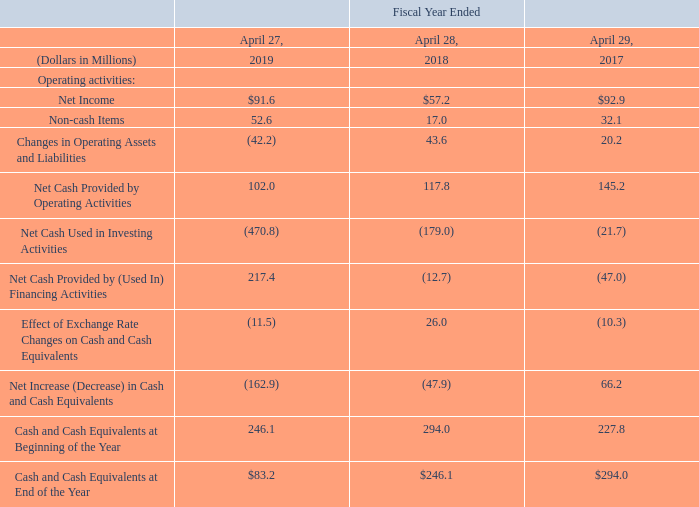Financial Condition, Liquidity and Capital Resources
We believe our current world-wide cash balances together with expected future cash flows to be generated from operations and our committed credit facility will be sufficient to support current operations. A significant amount of cash and expected future cash flows are located outside of the U.S. Of the $83.2 million of cash and cash equivalents as of April 27, 2019, $69.9 million was held in subsidiaries outside the U.S. and can be repatriated, primarily through the repayment of intercompany loans and the payment of dividends, without creating material additional income tax expense.
Cash flow is summarized below:
Operating Activities — Fiscal 2019 Compared to Fiscal 2018
Net cash provided by operating activities decreased $15.8 million to $102.0 million for fiscal 2019, compared to $117.8 million for fiscal 2018. The decrease was due to lower cash generated from changes in operating assets and liabilities, partially offset by higher net income adjusted for non-cash items. The $42.2 million of cash outflows for operating assets and liabilities was primarily due to higher prepaid expenses and other assets and lower accounts payable and accrued expenses.
Operating Activities — Fiscal 2018 Compared to Fiscal 2017
Net cash provided by operating activities decreased $27.4 million to $117.8 million in fiscal 2018, compared to $145.2 million in fiscal 2017. The decrease was primarily due to lower net income adjusted for non-cash items, partially offset by cash generated from changes in operating assets and liabilities. The $43.6 million of cash inflows for operating assets and liabilities was due to higher accounts payable and accrued expenses and lower prepaid expenses and other assets, offset by higher inventory levels.
Investing Activities — Fiscal 2019 Compared to Fiscal 2018
Net cash used in investing activities increased by $291.8 million to $470.8 million in fiscal 2019, compared to $179.0 million in fiscal 2018, primarily due to acquisitions. In fiscal 2019, we paid $422.1 million for the acquisition of Grakon. In fiscal 2018, we paid $130.9 million for the acquisitions of Pacific Insight and Procoplast.
Investing Activities — Fiscal 2018 Compared to Fiscal 2017
Net cash used in investing activities increased by $157.3 million to $179.0 million in fiscal 2018, compared to $21.7 million in fiscal 2017. The increase was primarily due to $130.9 million paid for the acquisitions of Pacific Insight and Procoplast. In addition, purchases of property, plant and equipment for our operations were higher in fiscal 2018 compared to fiscal 2017.
Financing Activities — Fiscal 2019 Compared to Fiscal 2018
Net cash provided by financing activities was $217.4 million in fiscal 2019, compared to net cash used in financing activities of $12.7 million in fiscal 2018. During fiscal 2019, we had net borrowings of $238.5 million which was partially used to fund the acquisition of Grakon. We paid dividends of $16.3 million in fiscal 2019, compared to $14.7 million in fiscal 2018.
Financing Activities — Fiscal 2018 Compared to Fiscal 2017
Net cash used in financing activities decreased $34.3 million to $12.7 million in fiscal 2018, compared to $47.0 million in fiscal 2017. During fiscal 2018, we had net borrowings of $2.0 million, compared to repayments on borrowings of $30.0 million in fiscal 2017. We paid dividends of $14.7 million and $13.7 million in fiscal 2018 and fiscal 2017, respectively. We did not repurchase any common stock in fiscal 2018. In fiscal 2017, we paid $9.8 million for the repurchase of common stock.
How much did Net cash provided by operating activities decreased from fiscal 2019 to 2018? $15.8 million. What led to decrease in Net cash provided by operating activities? Due to lower cash generated from changes in operating assets and liabilities, partially offset by higher net income adjusted for non-cash items. How much did Net cash provided by operating activities decreased from fiscal 2018 to 2017? $27.4 million. What is the change in Net Cash Provided by Operating Activities from Fiscal Year Ended April 28, 2018 to Fiscal Year Ended April 27, 2019?
Answer scale should be: million. 102.0-117.8
Answer: -15.8. What is the change in Net Cash Used in Investing Activities from Fiscal Year Ended April 28, 2018 to Fiscal Year Ended April 27, 2019?
Answer scale should be: million. -470.8-(-179.0)
Answer: -291.8. What is the change in Effect of Exchange Rate Changes on Cash and Cash Equivalents from Fiscal Year Ended April 28, 2018 to Fiscal Year Ended April 27, 2019?
Answer scale should be: million. -11.5-26.0
Answer: -37.5. 